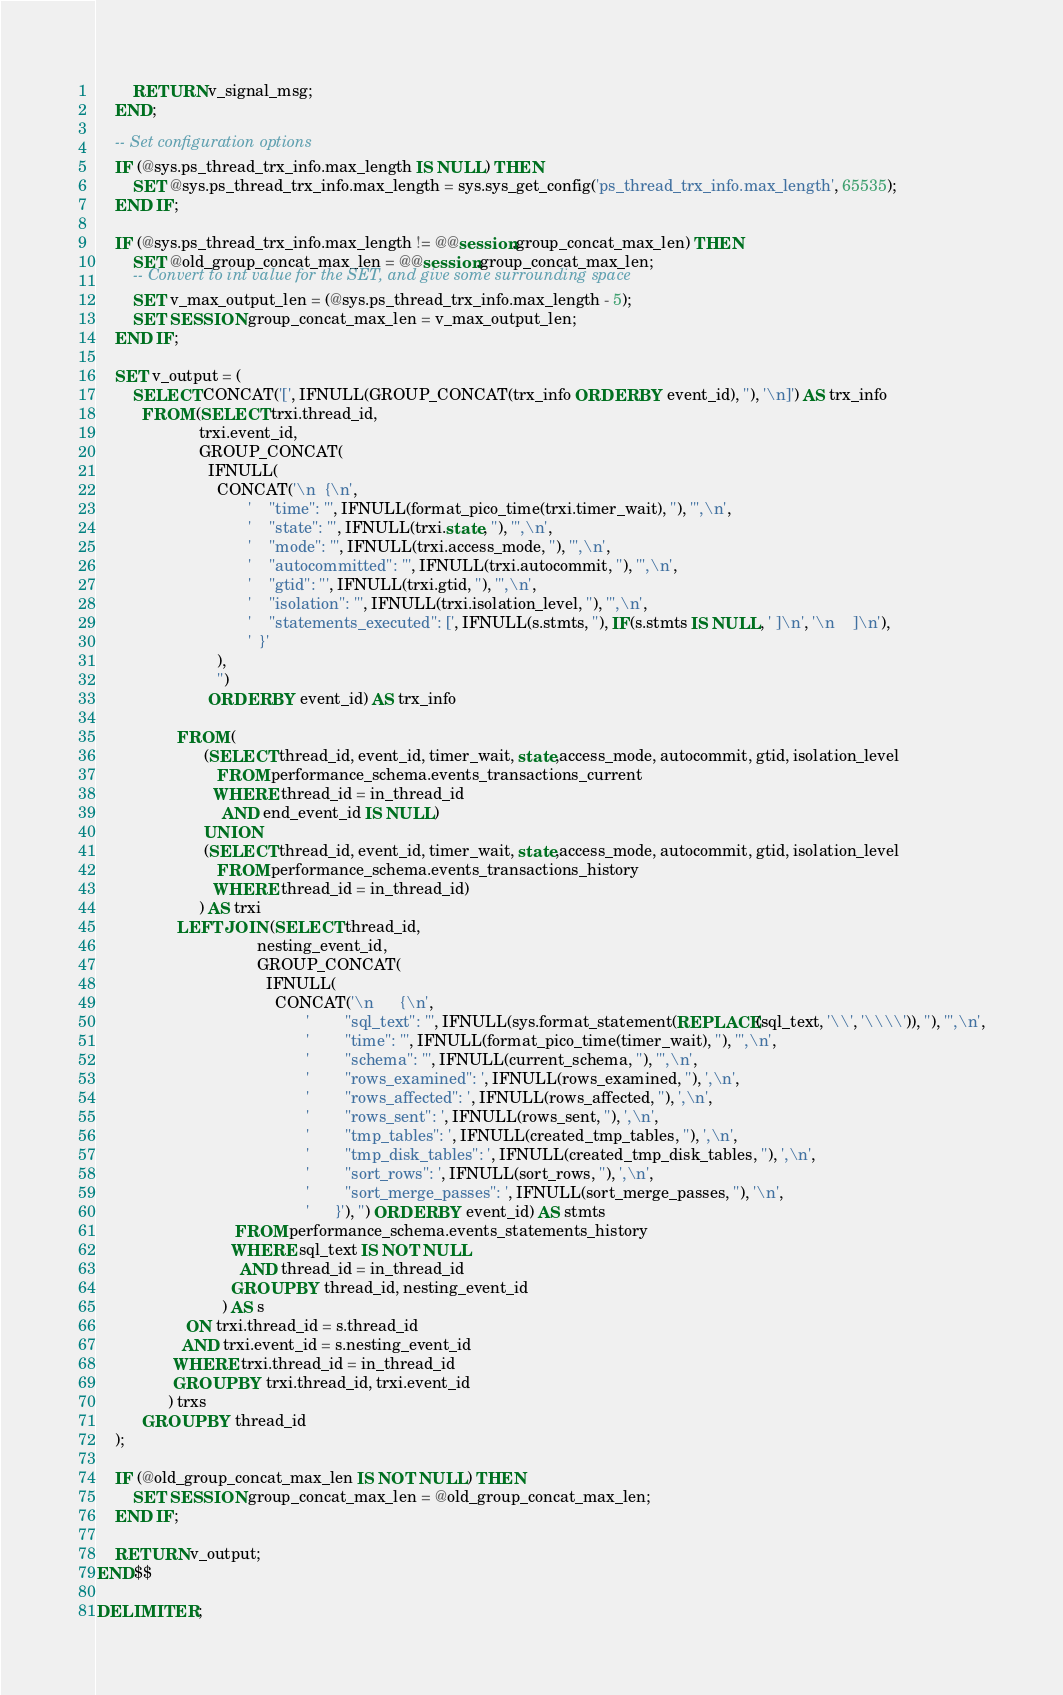<code> <loc_0><loc_0><loc_500><loc_500><_SQL_>
        RETURN v_signal_msg;
    END;

    -- Set configuration options
    IF (@sys.ps_thread_trx_info.max_length IS NULL) THEN
        SET @sys.ps_thread_trx_info.max_length = sys.sys_get_config('ps_thread_trx_info.max_length', 65535);
    END IF;

    IF (@sys.ps_thread_trx_info.max_length != @@session.group_concat_max_len) THEN
        SET @old_group_concat_max_len = @@session.group_concat_max_len;
        -- Convert to int value for the SET, and give some surrounding space
        SET v_max_output_len = (@sys.ps_thread_trx_info.max_length - 5);
        SET SESSION group_concat_max_len = v_max_output_len;
    END IF;

    SET v_output = (
        SELECT CONCAT('[', IFNULL(GROUP_CONCAT(trx_info ORDER BY event_id), ''), '\n]') AS trx_info
          FROM (SELECT trxi.thread_id, 
                       trxi.event_id,
                       GROUP_CONCAT(
                         IFNULL(
                           CONCAT('\n  {\n',
                                  '    "time": "', IFNULL(format_pico_time(trxi.timer_wait), ''), '",\n',
                                  '    "state": "', IFNULL(trxi.state, ''), '",\n',
                                  '    "mode": "', IFNULL(trxi.access_mode, ''), '",\n',
                                  '    "autocommitted": "', IFNULL(trxi.autocommit, ''), '",\n',
                                  '    "gtid": "', IFNULL(trxi.gtid, ''), '",\n',
                                  '    "isolation": "', IFNULL(trxi.isolation_level, ''), '",\n',
                                  '    "statements_executed": [', IFNULL(s.stmts, ''), IF(s.stmts IS NULL, ' ]\n', '\n    ]\n'),
                                  '  }'
                           ), 
                           '') 
                         ORDER BY event_id) AS trx_info

                  FROM (
                        (SELECT thread_id, event_id, timer_wait, state,access_mode, autocommit, gtid, isolation_level
                           FROM performance_schema.events_transactions_current
                          WHERE thread_id = in_thread_id
                            AND end_event_id IS NULL)
                        UNION
                        (SELECT thread_id, event_id, timer_wait, state,access_mode, autocommit, gtid, isolation_level
                           FROM performance_schema.events_transactions_history
                          WHERE thread_id = in_thread_id)
                       ) AS trxi
                  LEFT JOIN (SELECT thread_id,
                                    nesting_event_id,
                                    GROUP_CONCAT(
                                      IFNULL(
                                        CONCAT('\n      {\n',
                                               '        "sql_text": "', IFNULL(sys.format_statement(REPLACE(sql_text, '\\', '\\\\')), ''), '",\n',
                                               '        "time": "', IFNULL(format_pico_time(timer_wait), ''), '",\n',
                                               '        "schema": "', IFNULL(current_schema, ''), '",\n',
                                               '        "rows_examined": ', IFNULL(rows_examined, ''), ',\n',
                                               '        "rows_affected": ', IFNULL(rows_affected, ''), ',\n',
                                               '        "rows_sent": ', IFNULL(rows_sent, ''), ',\n',
                                               '        "tmp_tables": ', IFNULL(created_tmp_tables, ''), ',\n',
                                               '        "tmp_disk_tables": ', IFNULL(created_tmp_disk_tables, ''), ',\n',
                                               '        "sort_rows": ', IFNULL(sort_rows, ''), ',\n',
                                               '        "sort_merge_passes": ', IFNULL(sort_merge_passes, ''), '\n',
                                               '      }'), '') ORDER BY event_id) AS stmts
                               FROM performance_schema.events_statements_history
                              WHERE sql_text IS NOT NULL
                                AND thread_id = in_thread_id
                              GROUP BY thread_id, nesting_event_id
                            ) AS s 
                    ON trxi.thread_id = s.thread_id 
                   AND trxi.event_id = s.nesting_event_id
                 WHERE trxi.thread_id = in_thread_id
                 GROUP BY trxi.thread_id, trxi.event_id
                ) trxs
          GROUP BY thread_id
    );

    IF (@old_group_concat_max_len IS NOT NULL) THEN
        SET SESSION group_concat_max_len = @old_group_concat_max_len;
    END IF;

    RETURN v_output;
END$$

DELIMITER ;
</code> 